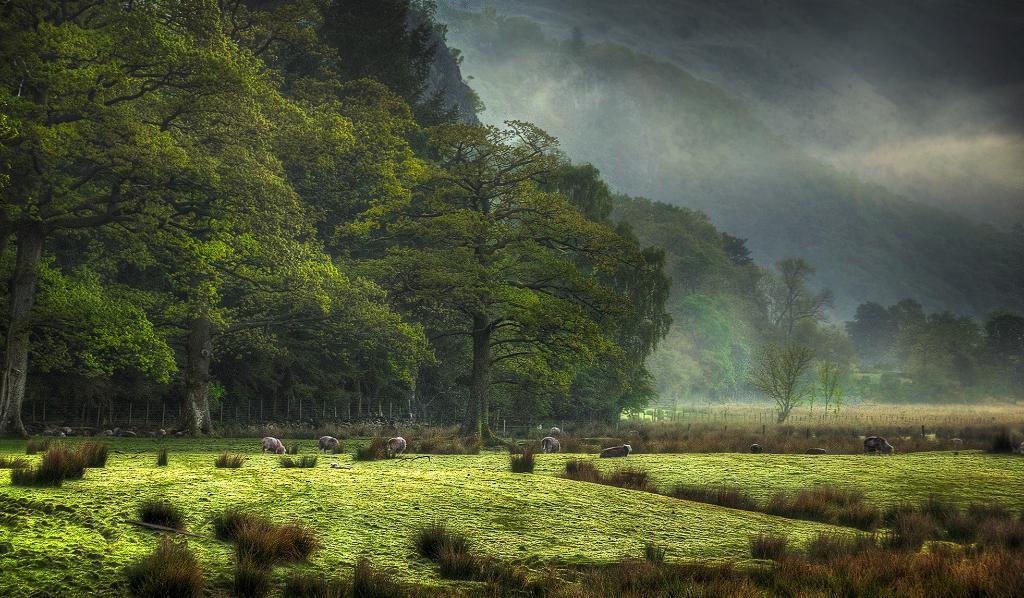Please provide a concise description of this image. In this image there are trees and we can see animals. At the bottom there is grass. In the background there are hills and sky. 